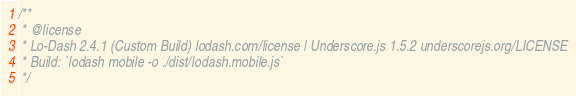<code> <loc_0><loc_0><loc_500><loc_500><_JavaScript_>/**
 * @license
 * Lo-Dash 2.4.1 (Custom Build) lodash.com/license | Underscore.js 1.5.2 underscorejs.org/LICENSE
 * Build: `lodash mobile -o ./dist/lodash.mobile.js`
 */</code> 